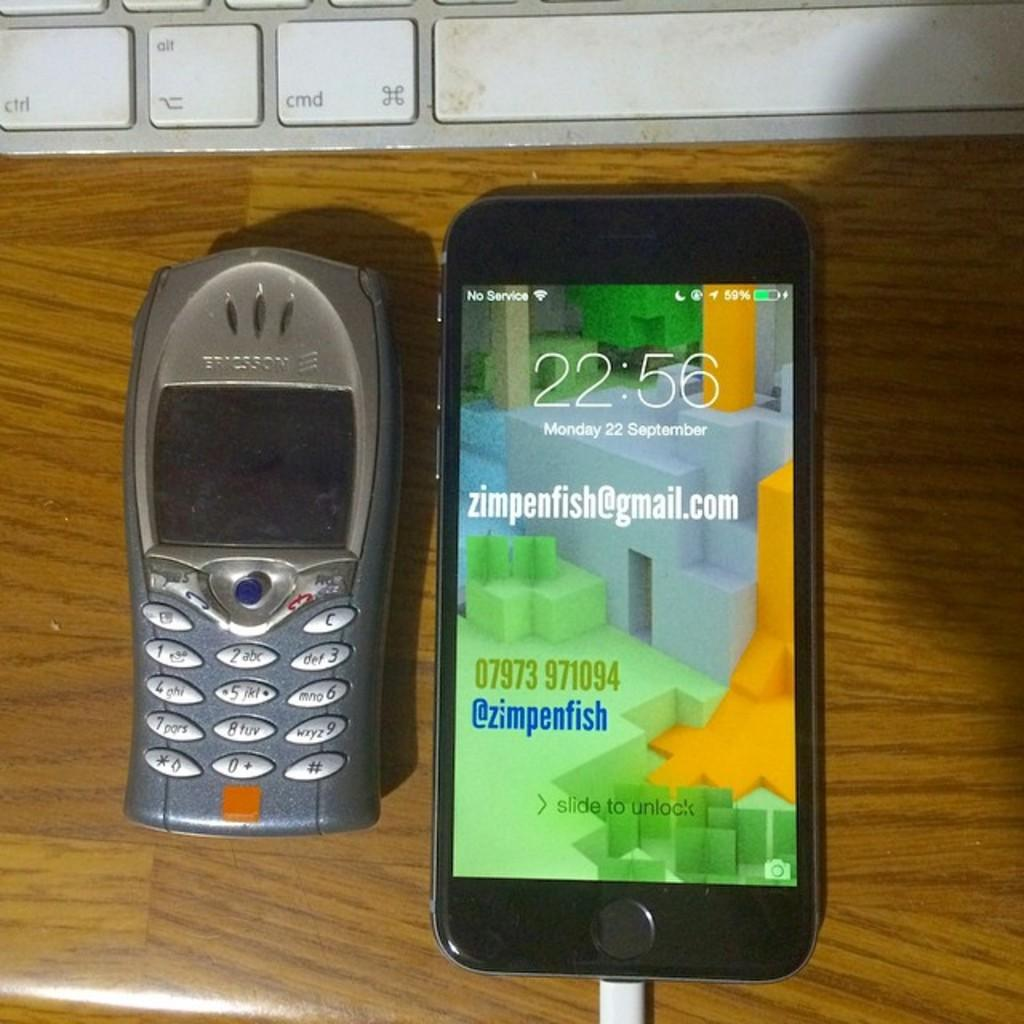<image>
Summarize the visual content of the image. two cell phones on a table with one reading NO SERVICE 